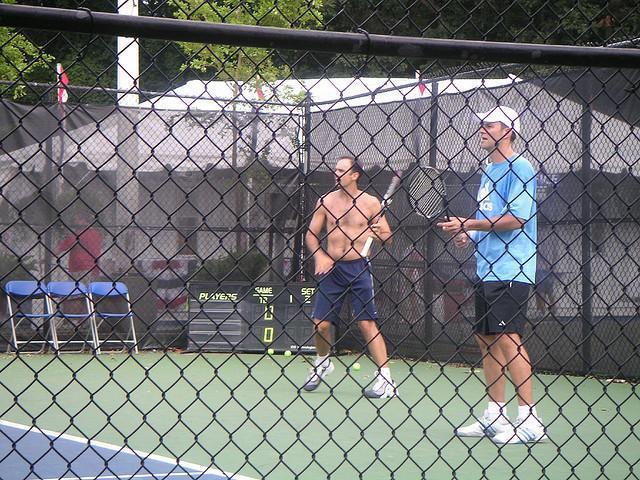How many men are wearing hats?
Give a very brief answer. 1. How many chairs are there?
Give a very brief answer. 3. How many people are visible?
Give a very brief answer. 3. 